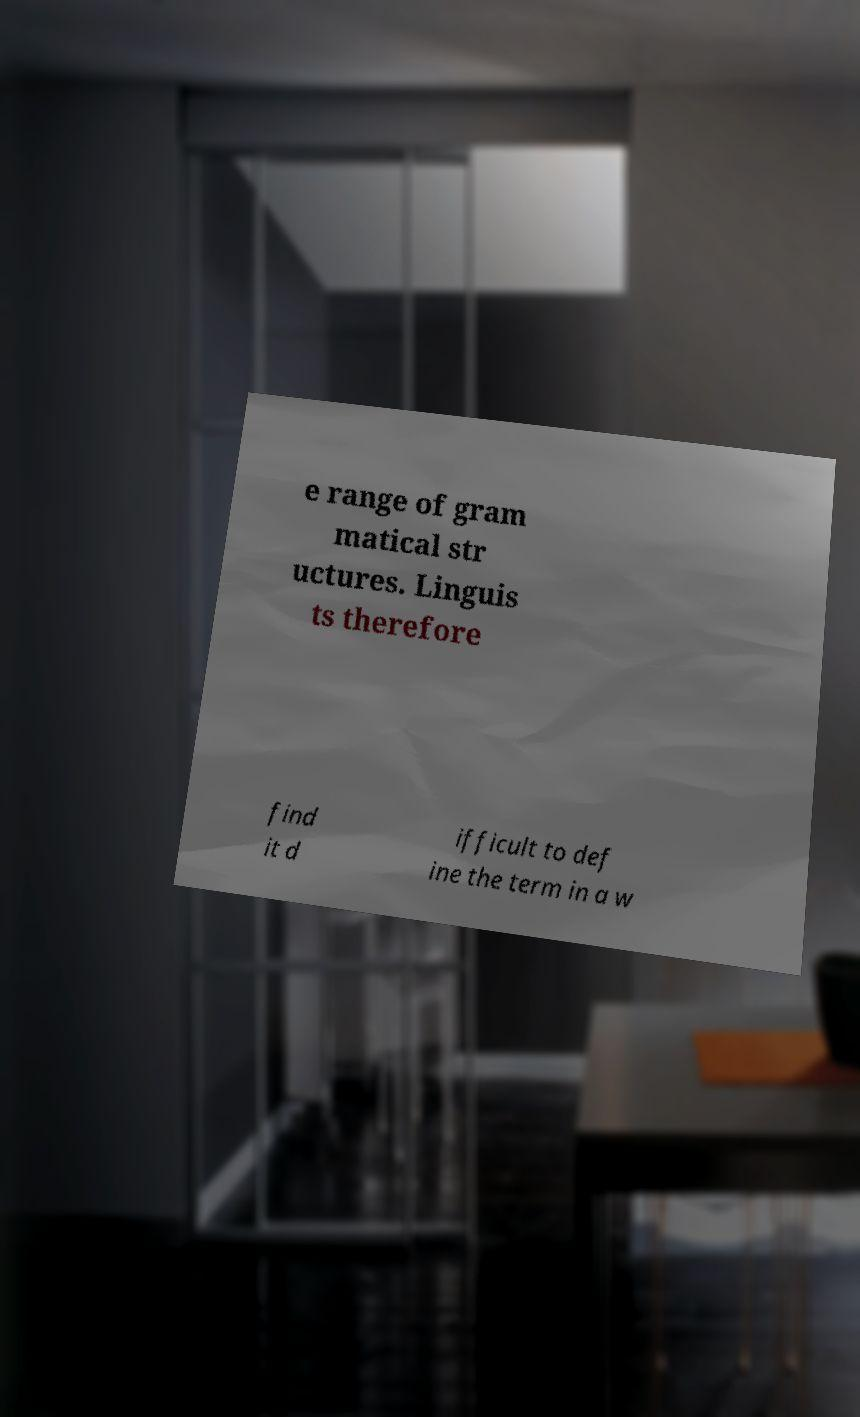Please read and relay the text visible in this image. What does it say? e range of gram matical str uctures. Linguis ts therefore find it d ifficult to def ine the term in a w 